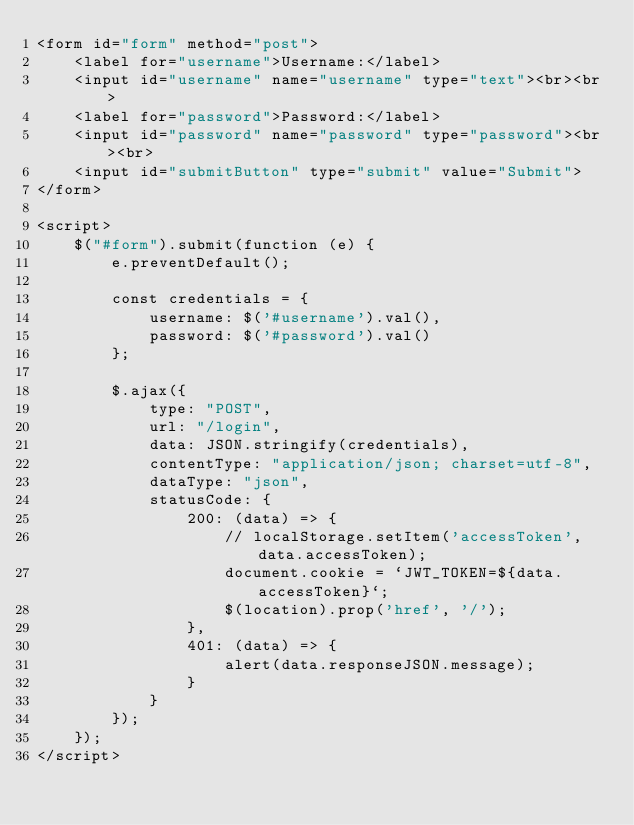<code> <loc_0><loc_0><loc_500><loc_500><_HTML_><form id="form" method="post">
    <label for="username">Username:</label>
    <input id="username" name="username" type="text"><br><br>
    <label for="password">Password:</label>
    <input id="password" name="password" type="password"><br><br>
    <input id="submitButton" type="submit" value="Submit">
</form>

<script>
    $("#form").submit(function (e) {
        e.preventDefault();

        const credentials = {
            username: $('#username').val(),
            password: $('#password').val()
        };

        $.ajax({
            type: "POST",
            url: "/login",
            data: JSON.stringify(credentials),
            contentType: "application/json; charset=utf-8",
            dataType: "json",
            statusCode: {
                200: (data) => {
                    // localStorage.setItem('accessToken', data.accessToken);
                    document.cookie = `JWT_TOKEN=${data.accessToken}`;
                    $(location).prop('href', '/');
                },
                401: (data) => {
                    alert(data.responseJSON.message);
                }
            }
        });
    });
</script>
</code> 